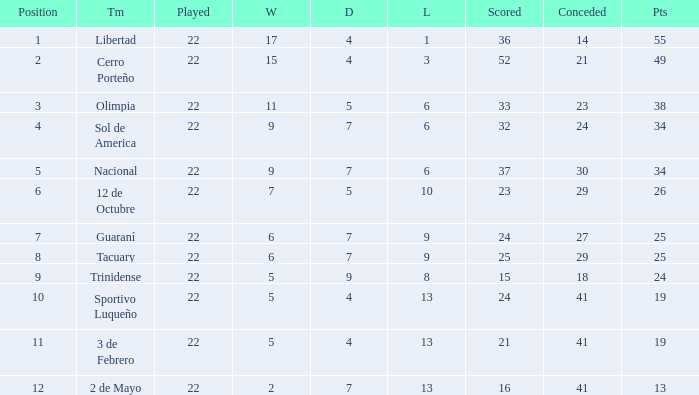What is the number of draws for the team with more than 8 losses and 13 points? 7.0. 